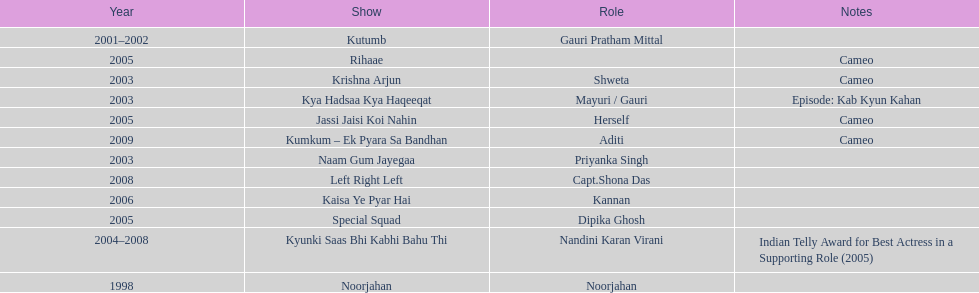Besides rihaae, in what other show did gauri tejwani cameo in 2005? Jassi Jaisi Koi Nahin. 